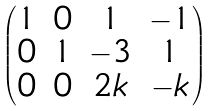<formula> <loc_0><loc_0><loc_500><loc_500>\begin{pmatrix} 1 & 0 & 1 & - 1 \\ 0 & 1 & - 3 & 1 \\ 0 & 0 & 2 k & - k \\ \end{pmatrix}</formula> 